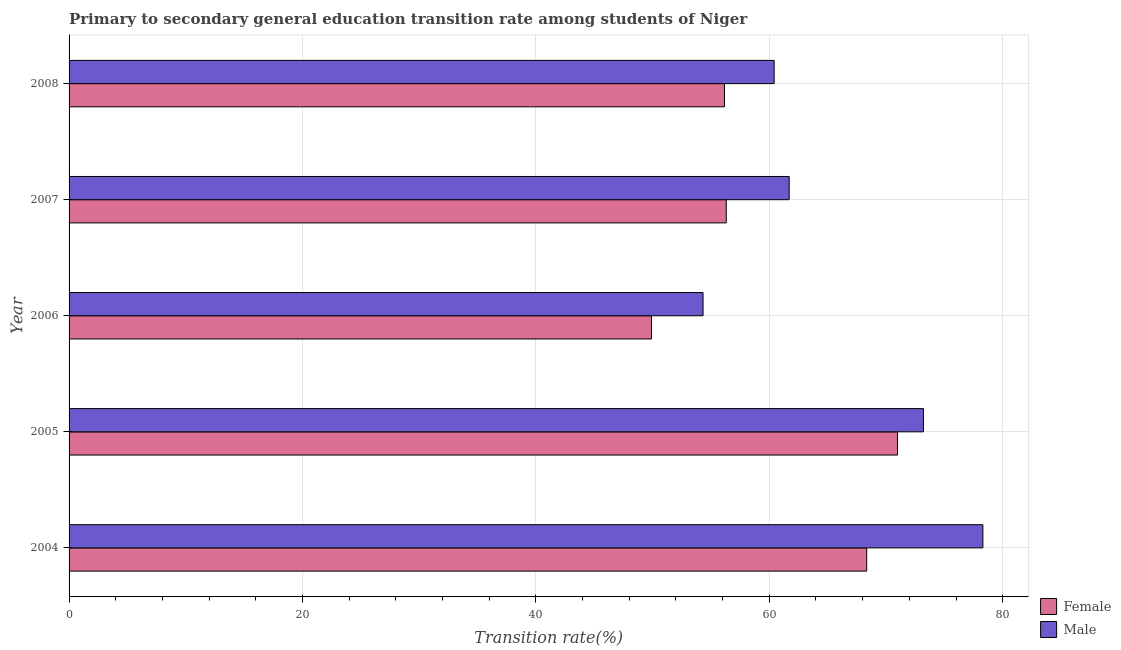How many different coloured bars are there?
Ensure brevity in your answer.  2. How many groups of bars are there?
Provide a short and direct response. 5. How many bars are there on the 2nd tick from the bottom?
Ensure brevity in your answer.  2. What is the label of the 4th group of bars from the top?
Offer a very short reply. 2005. In how many cases, is the number of bars for a given year not equal to the number of legend labels?
Your response must be concise. 0. What is the transition rate among female students in 2005?
Provide a short and direct response. 70.99. Across all years, what is the maximum transition rate among male students?
Offer a terse response. 78.3. Across all years, what is the minimum transition rate among male students?
Offer a terse response. 54.33. In which year was the transition rate among male students minimum?
Your answer should be compact. 2006. What is the total transition rate among male students in the graph?
Your response must be concise. 327.96. What is the difference between the transition rate among female students in 2005 and that in 2007?
Give a very brief answer. 14.67. What is the difference between the transition rate among female students in 2008 and the transition rate among male students in 2004?
Give a very brief answer. -22.14. What is the average transition rate among male students per year?
Ensure brevity in your answer.  65.59. In the year 2007, what is the difference between the transition rate among male students and transition rate among female students?
Your answer should be compact. 5.39. In how many years, is the transition rate among male students greater than 72 %?
Your answer should be very brief. 2. What is the ratio of the transition rate among male students in 2004 to that in 2008?
Provide a short and direct response. 1.3. Is the transition rate among female students in 2006 less than that in 2007?
Your response must be concise. Yes. What is the difference between the highest and the second highest transition rate among male students?
Offer a very short reply. 5.1. What is the difference between the highest and the lowest transition rate among female students?
Your answer should be compact. 21.08. What does the 2nd bar from the top in 2007 represents?
Your response must be concise. Female. What does the 2nd bar from the bottom in 2005 represents?
Keep it short and to the point. Male. How many bars are there?
Your answer should be very brief. 10. Does the graph contain any zero values?
Make the answer very short. No. Where does the legend appear in the graph?
Keep it short and to the point. Bottom right. How many legend labels are there?
Offer a very short reply. 2. How are the legend labels stacked?
Provide a short and direct response. Vertical. What is the title of the graph?
Your response must be concise. Primary to secondary general education transition rate among students of Niger. Does "Secondary school" appear as one of the legend labels in the graph?
Provide a short and direct response. No. What is the label or title of the X-axis?
Your response must be concise. Transition rate(%). What is the Transition rate(%) of Female in 2004?
Make the answer very short. 68.35. What is the Transition rate(%) of Male in 2004?
Make the answer very short. 78.3. What is the Transition rate(%) in Female in 2005?
Your answer should be compact. 70.99. What is the Transition rate(%) in Male in 2005?
Keep it short and to the point. 73.21. What is the Transition rate(%) of Female in 2006?
Your answer should be very brief. 49.91. What is the Transition rate(%) of Male in 2006?
Provide a succinct answer. 54.33. What is the Transition rate(%) of Female in 2007?
Provide a short and direct response. 56.31. What is the Transition rate(%) of Male in 2007?
Your answer should be compact. 61.71. What is the Transition rate(%) in Female in 2008?
Offer a very short reply. 56.16. What is the Transition rate(%) of Male in 2008?
Ensure brevity in your answer.  60.42. Across all years, what is the maximum Transition rate(%) of Female?
Offer a terse response. 70.99. Across all years, what is the maximum Transition rate(%) in Male?
Your answer should be very brief. 78.3. Across all years, what is the minimum Transition rate(%) of Female?
Keep it short and to the point. 49.91. Across all years, what is the minimum Transition rate(%) of Male?
Your answer should be very brief. 54.33. What is the total Transition rate(%) in Female in the graph?
Offer a very short reply. 301.72. What is the total Transition rate(%) of Male in the graph?
Your answer should be compact. 327.96. What is the difference between the Transition rate(%) in Female in 2004 and that in 2005?
Provide a short and direct response. -2.64. What is the difference between the Transition rate(%) in Male in 2004 and that in 2005?
Keep it short and to the point. 5.1. What is the difference between the Transition rate(%) in Female in 2004 and that in 2006?
Your answer should be compact. 18.44. What is the difference between the Transition rate(%) in Male in 2004 and that in 2006?
Keep it short and to the point. 23.98. What is the difference between the Transition rate(%) in Female in 2004 and that in 2007?
Keep it short and to the point. 12.04. What is the difference between the Transition rate(%) in Male in 2004 and that in 2007?
Your answer should be very brief. 16.6. What is the difference between the Transition rate(%) of Female in 2004 and that in 2008?
Make the answer very short. 12.19. What is the difference between the Transition rate(%) of Male in 2004 and that in 2008?
Offer a very short reply. 17.89. What is the difference between the Transition rate(%) of Female in 2005 and that in 2006?
Give a very brief answer. 21.08. What is the difference between the Transition rate(%) in Male in 2005 and that in 2006?
Your response must be concise. 18.88. What is the difference between the Transition rate(%) of Female in 2005 and that in 2007?
Your answer should be compact. 14.67. What is the difference between the Transition rate(%) in Male in 2005 and that in 2007?
Ensure brevity in your answer.  11.5. What is the difference between the Transition rate(%) in Female in 2005 and that in 2008?
Ensure brevity in your answer.  14.83. What is the difference between the Transition rate(%) of Male in 2005 and that in 2008?
Make the answer very short. 12.79. What is the difference between the Transition rate(%) of Female in 2006 and that in 2007?
Give a very brief answer. -6.41. What is the difference between the Transition rate(%) of Male in 2006 and that in 2007?
Offer a very short reply. -7.38. What is the difference between the Transition rate(%) of Female in 2006 and that in 2008?
Ensure brevity in your answer.  -6.25. What is the difference between the Transition rate(%) of Male in 2006 and that in 2008?
Offer a terse response. -6.09. What is the difference between the Transition rate(%) of Female in 2007 and that in 2008?
Make the answer very short. 0.15. What is the difference between the Transition rate(%) of Male in 2007 and that in 2008?
Keep it short and to the point. 1.29. What is the difference between the Transition rate(%) in Female in 2004 and the Transition rate(%) in Male in 2005?
Your answer should be compact. -4.86. What is the difference between the Transition rate(%) of Female in 2004 and the Transition rate(%) of Male in 2006?
Ensure brevity in your answer.  14.02. What is the difference between the Transition rate(%) in Female in 2004 and the Transition rate(%) in Male in 2007?
Offer a terse response. 6.64. What is the difference between the Transition rate(%) in Female in 2004 and the Transition rate(%) in Male in 2008?
Your answer should be compact. 7.93. What is the difference between the Transition rate(%) of Female in 2005 and the Transition rate(%) of Male in 2006?
Your response must be concise. 16.66. What is the difference between the Transition rate(%) in Female in 2005 and the Transition rate(%) in Male in 2007?
Ensure brevity in your answer.  9.28. What is the difference between the Transition rate(%) of Female in 2005 and the Transition rate(%) of Male in 2008?
Offer a terse response. 10.57. What is the difference between the Transition rate(%) in Female in 2006 and the Transition rate(%) in Male in 2007?
Your response must be concise. -11.8. What is the difference between the Transition rate(%) in Female in 2006 and the Transition rate(%) in Male in 2008?
Keep it short and to the point. -10.51. What is the difference between the Transition rate(%) in Female in 2007 and the Transition rate(%) in Male in 2008?
Give a very brief answer. -4.1. What is the average Transition rate(%) of Female per year?
Offer a very short reply. 60.34. What is the average Transition rate(%) in Male per year?
Your answer should be very brief. 65.59. In the year 2004, what is the difference between the Transition rate(%) of Female and Transition rate(%) of Male?
Your answer should be very brief. -9.96. In the year 2005, what is the difference between the Transition rate(%) in Female and Transition rate(%) in Male?
Your answer should be very brief. -2.22. In the year 2006, what is the difference between the Transition rate(%) in Female and Transition rate(%) in Male?
Your answer should be very brief. -4.42. In the year 2007, what is the difference between the Transition rate(%) in Female and Transition rate(%) in Male?
Give a very brief answer. -5.39. In the year 2008, what is the difference between the Transition rate(%) of Female and Transition rate(%) of Male?
Make the answer very short. -4.26. What is the ratio of the Transition rate(%) of Female in 2004 to that in 2005?
Give a very brief answer. 0.96. What is the ratio of the Transition rate(%) in Male in 2004 to that in 2005?
Keep it short and to the point. 1.07. What is the ratio of the Transition rate(%) in Female in 2004 to that in 2006?
Ensure brevity in your answer.  1.37. What is the ratio of the Transition rate(%) in Male in 2004 to that in 2006?
Your response must be concise. 1.44. What is the ratio of the Transition rate(%) of Female in 2004 to that in 2007?
Your response must be concise. 1.21. What is the ratio of the Transition rate(%) of Male in 2004 to that in 2007?
Provide a succinct answer. 1.27. What is the ratio of the Transition rate(%) of Female in 2004 to that in 2008?
Offer a terse response. 1.22. What is the ratio of the Transition rate(%) of Male in 2004 to that in 2008?
Ensure brevity in your answer.  1.3. What is the ratio of the Transition rate(%) of Female in 2005 to that in 2006?
Your answer should be compact. 1.42. What is the ratio of the Transition rate(%) of Male in 2005 to that in 2006?
Your answer should be compact. 1.35. What is the ratio of the Transition rate(%) of Female in 2005 to that in 2007?
Your answer should be compact. 1.26. What is the ratio of the Transition rate(%) in Male in 2005 to that in 2007?
Offer a very short reply. 1.19. What is the ratio of the Transition rate(%) of Female in 2005 to that in 2008?
Ensure brevity in your answer.  1.26. What is the ratio of the Transition rate(%) in Male in 2005 to that in 2008?
Provide a succinct answer. 1.21. What is the ratio of the Transition rate(%) in Female in 2006 to that in 2007?
Ensure brevity in your answer.  0.89. What is the ratio of the Transition rate(%) in Male in 2006 to that in 2007?
Your answer should be compact. 0.88. What is the ratio of the Transition rate(%) of Female in 2006 to that in 2008?
Provide a short and direct response. 0.89. What is the ratio of the Transition rate(%) in Male in 2006 to that in 2008?
Make the answer very short. 0.9. What is the ratio of the Transition rate(%) of Female in 2007 to that in 2008?
Provide a succinct answer. 1. What is the ratio of the Transition rate(%) of Male in 2007 to that in 2008?
Ensure brevity in your answer.  1.02. What is the difference between the highest and the second highest Transition rate(%) in Female?
Provide a short and direct response. 2.64. What is the difference between the highest and the second highest Transition rate(%) in Male?
Offer a very short reply. 5.1. What is the difference between the highest and the lowest Transition rate(%) of Female?
Your response must be concise. 21.08. What is the difference between the highest and the lowest Transition rate(%) of Male?
Give a very brief answer. 23.98. 